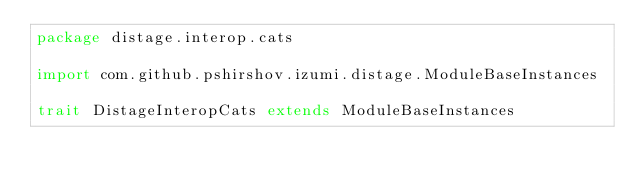<code> <loc_0><loc_0><loc_500><loc_500><_Scala_>package distage.interop.cats

import com.github.pshirshov.izumi.distage.ModuleBaseInstances

trait DistageInteropCats extends ModuleBaseInstances
</code> 